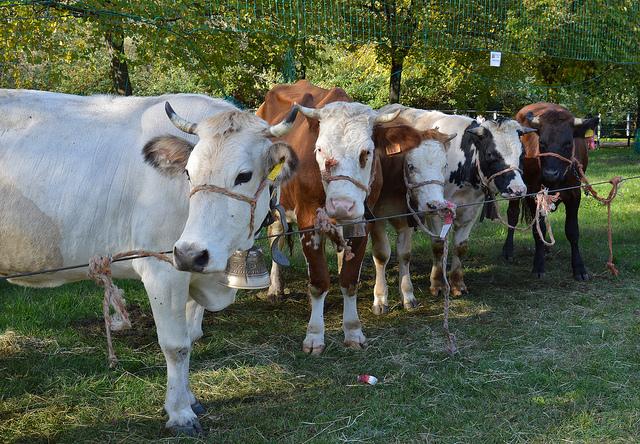Do these cows seem to be upset?
Answer briefly. No. How did these cow owners mark them?
Quick response, please. Ear tags. Where are the cows?
Short answer required. Farm. 